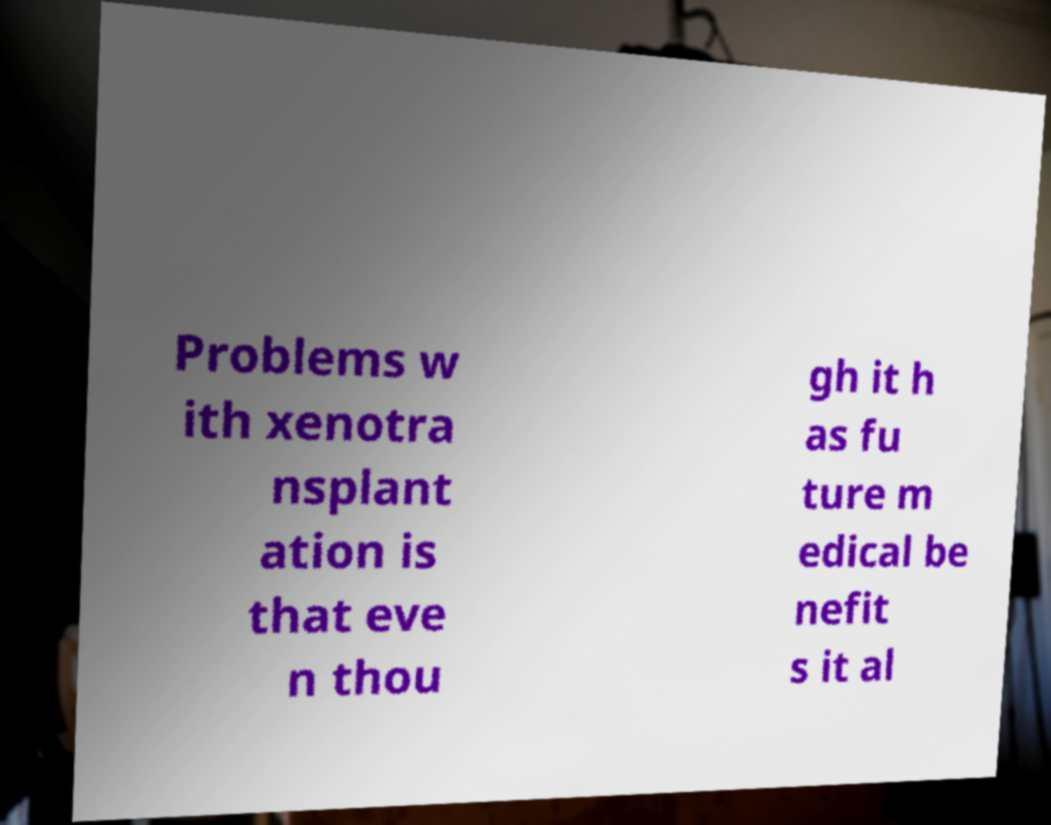Could you extract and type out the text from this image? Problems w ith xenotra nsplant ation is that eve n thou gh it h as fu ture m edical be nefit s it al 